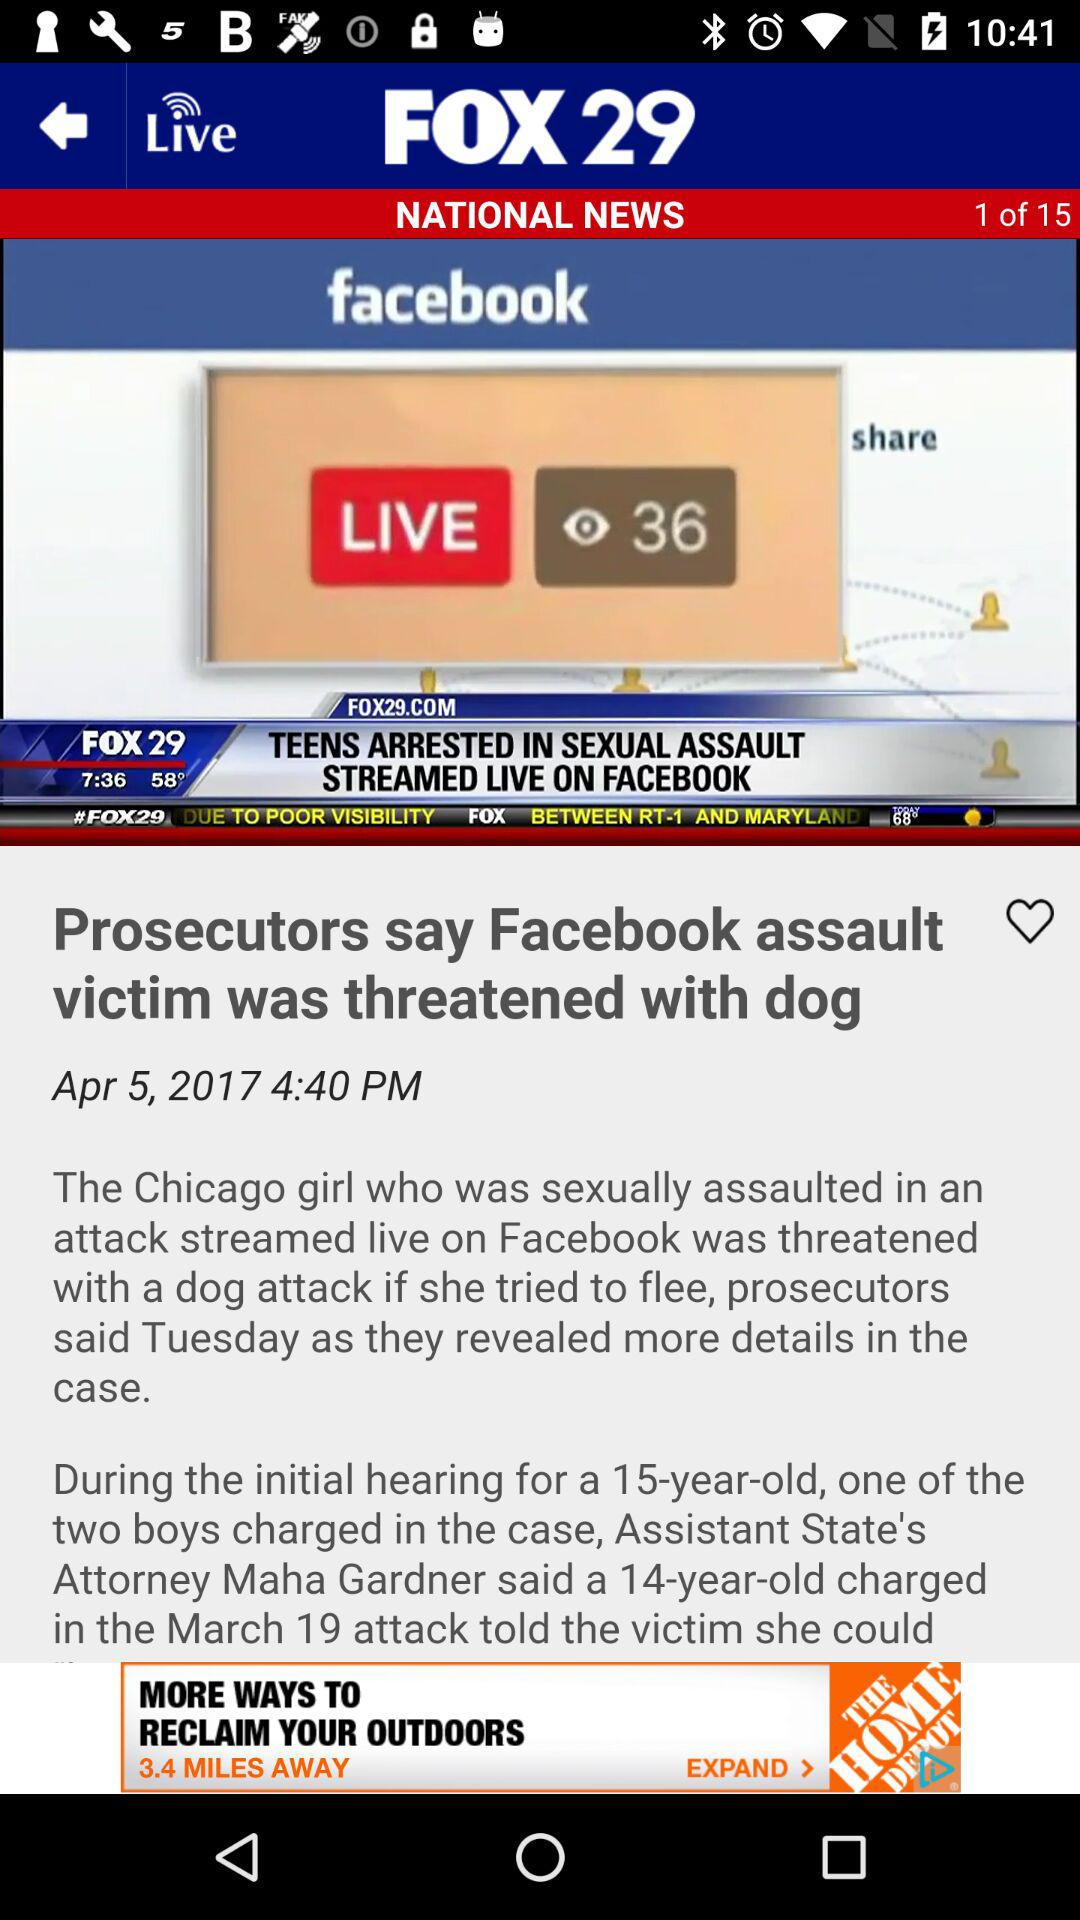What is the news channel's name? The news channel's name is "FOX 29". 